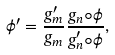<formula> <loc_0><loc_0><loc_500><loc_500>\phi ^ { \prime } = \frac { g _ { m } ^ { \prime } } { g _ { m } } \frac { g _ { n } \circ \phi } { g _ { n } ^ { \prime } \circ \phi } ,</formula> 